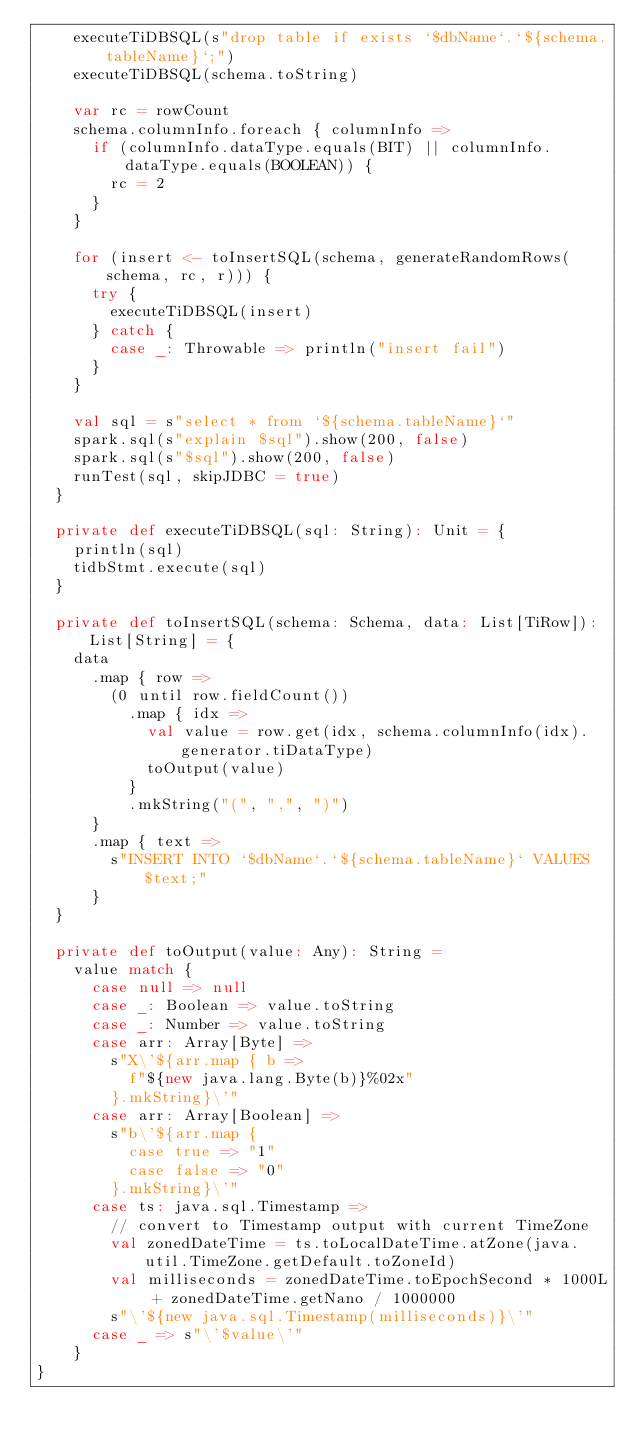Convert code to text. <code><loc_0><loc_0><loc_500><loc_500><_Scala_>    executeTiDBSQL(s"drop table if exists `$dbName`.`${schema.tableName}`;")
    executeTiDBSQL(schema.toString)

    var rc = rowCount
    schema.columnInfo.foreach { columnInfo =>
      if (columnInfo.dataType.equals(BIT) || columnInfo.dataType.equals(BOOLEAN)) {
        rc = 2
      }
    }

    for (insert <- toInsertSQL(schema, generateRandomRows(schema, rc, r))) {
      try {
        executeTiDBSQL(insert)
      } catch {
        case _: Throwable => println("insert fail")
      }
    }

    val sql = s"select * from `${schema.tableName}`"
    spark.sql(s"explain $sql").show(200, false)
    spark.sql(s"$sql").show(200, false)
    runTest(sql, skipJDBC = true)
  }

  private def executeTiDBSQL(sql: String): Unit = {
    println(sql)
    tidbStmt.execute(sql)
  }

  private def toInsertSQL(schema: Schema, data: List[TiRow]): List[String] = {
    data
      .map { row =>
        (0 until row.fieldCount())
          .map { idx =>
            val value = row.get(idx, schema.columnInfo(idx).generator.tiDataType)
            toOutput(value)
          }
          .mkString("(", ",", ")")
      }
      .map { text =>
        s"INSERT INTO `$dbName`.`${schema.tableName}` VALUES $text;"
      }
  }

  private def toOutput(value: Any): String =
    value match {
      case null => null
      case _: Boolean => value.toString
      case _: Number => value.toString
      case arr: Array[Byte] =>
        s"X\'${arr.map { b =>
          f"${new java.lang.Byte(b)}%02x"
        }.mkString}\'"
      case arr: Array[Boolean] =>
        s"b\'${arr.map {
          case true => "1"
          case false => "0"
        }.mkString}\'"
      case ts: java.sql.Timestamp =>
        // convert to Timestamp output with current TimeZone
        val zonedDateTime = ts.toLocalDateTime.atZone(java.util.TimeZone.getDefault.toZoneId)
        val milliseconds = zonedDateTime.toEpochSecond * 1000L + zonedDateTime.getNano / 1000000
        s"\'${new java.sql.Timestamp(milliseconds)}\'"
      case _ => s"\'$value\'"
    }
}
</code> 